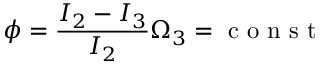<formula> <loc_0><loc_0><loc_500><loc_500>\phi = \frac { I _ { 2 } - I _ { 3 } } { I _ { 2 } } \Omega _ { 3 } = c o n s t</formula> 